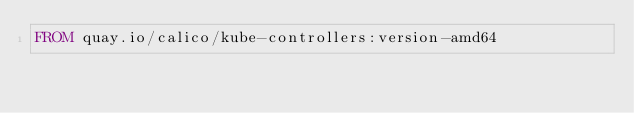Convert code to text. <code><loc_0><loc_0><loc_500><loc_500><_Dockerfile_>FROM quay.io/calico/kube-controllers:version-amd64
</code> 